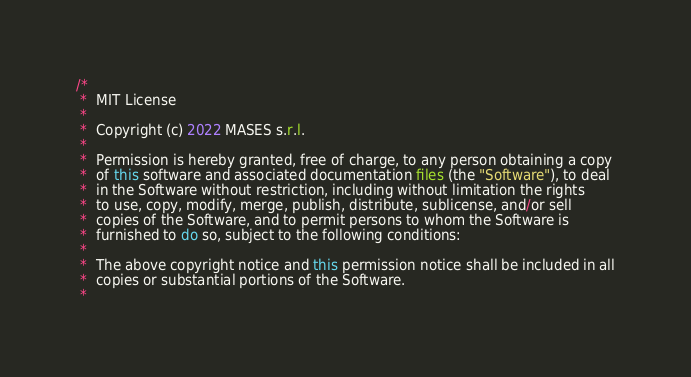<code> <loc_0><loc_0><loc_500><loc_500><_Java_>/*
 *  MIT License
 *
 *  Copyright (c) 2022 MASES s.r.l.
 *
 *  Permission is hereby granted, free of charge, to any person obtaining a copy
 *  of this software and associated documentation files (the "Software"), to deal
 *  in the Software without restriction, including without limitation the rights
 *  to use, copy, modify, merge, publish, distribute, sublicense, and/or sell
 *  copies of the Software, and to permit persons to whom the Software is
 *  furnished to do so, subject to the following conditions:
 *
 *  The above copyright notice and this permission notice shall be included in all
 *  copies or substantial portions of the Software.
 *</code> 